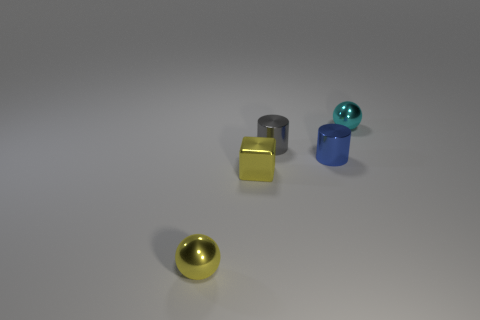What number of other objects are there of the same material as the gray cylinder?
Your answer should be very brief. 4. Do the gray thing and the yellow metal sphere have the same size?
Give a very brief answer. Yes. There is a tiny blue thing that is behind the small yellow shiny sphere; what shape is it?
Provide a succinct answer. Cylinder. There is a metallic sphere that is left of the shiny ball that is right of the small yellow shiny sphere; what color is it?
Your answer should be compact. Yellow. There is a shiny thing behind the tiny gray metal object; is its shape the same as the yellow thing that is behind the yellow ball?
Your answer should be very brief. No. There is a gray object that is the same size as the blue shiny cylinder; what shape is it?
Provide a succinct answer. Cylinder. There is a tiny cube that is the same material as the gray thing; what color is it?
Give a very brief answer. Yellow. Do the gray metal thing and the tiny shiny object in front of the cube have the same shape?
Give a very brief answer. No. There is a sphere that is the same color as the metallic cube; what material is it?
Provide a short and direct response. Metal. There is a yellow sphere that is the same size as the yellow block; what is it made of?
Your response must be concise. Metal. 